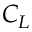<formula> <loc_0><loc_0><loc_500><loc_500>C _ { L }</formula> 